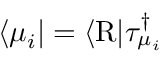Convert formula to latex. <formula><loc_0><loc_0><loc_500><loc_500>\begin{array} { r } { \langle \mu _ { i } | = \langle R | \tau _ { \mu _ { i } } ^ { \dagger } } \end{array}</formula> 